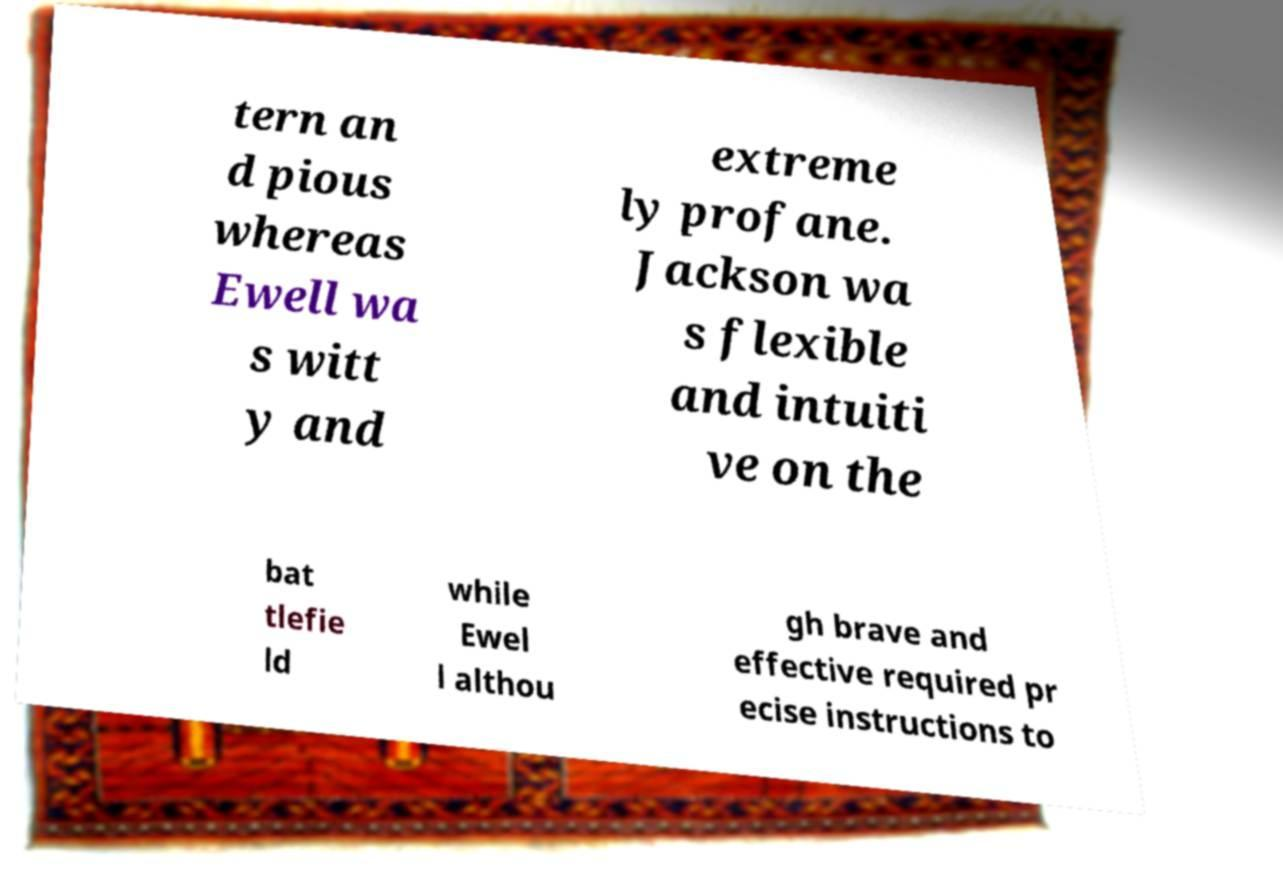Can you accurately transcribe the text from the provided image for me? tern an d pious whereas Ewell wa s witt y and extreme ly profane. Jackson wa s flexible and intuiti ve on the bat tlefie ld while Ewel l althou gh brave and effective required pr ecise instructions to 